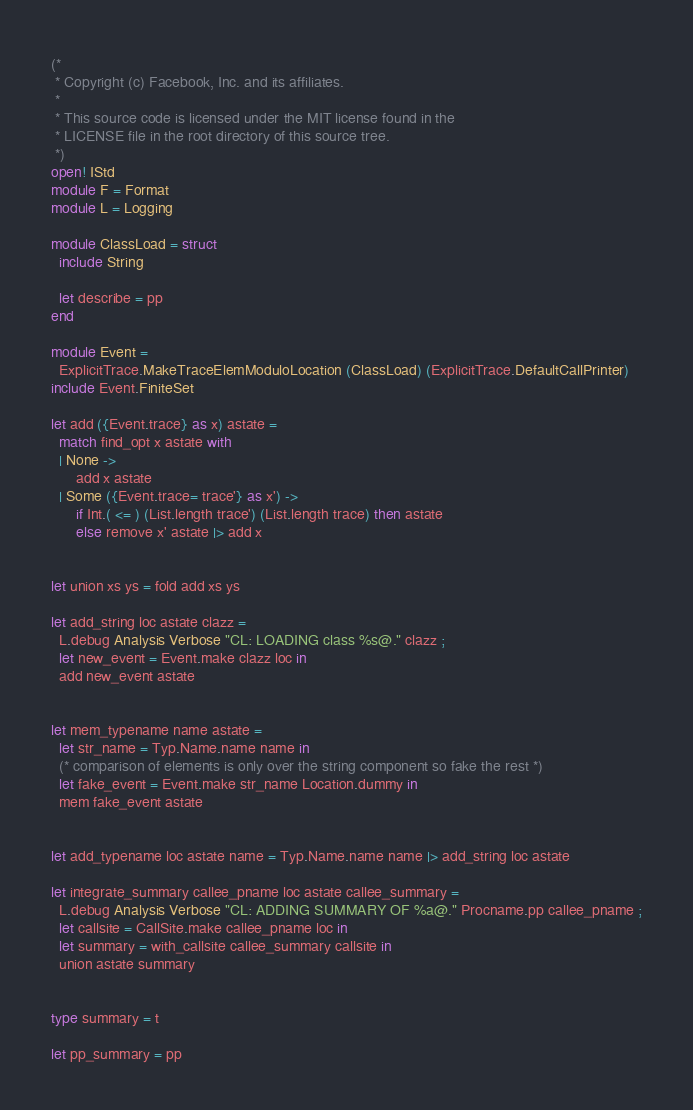<code> <loc_0><loc_0><loc_500><loc_500><_OCaml_>(*
 * Copyright (c) Facebook, Inc. and its affiliates.
 *
 * This source code is licensed under the MIT license found in the
 * LICENSE file in the root directory of this source tree.
 *)
open! IStd
module F = Format
module L = Logging

module ClassLoad = struct
  include String

  let describe = pp
end

module Event =
  ExplicitTrace.MakeTraceElemModuloLocation (ClassLoad) (ExplicitTrace.DefaultCallPrinter)
include Event.FiniteSet

let add ({Event.trace} as x) astate =
  match find_opt x astate with
  | None ->
      add x astate
  | Some ({Event.trace= trace'} as x') ->
      if Int.( <= ) (List.length trace') (List.length trace) then astate
      else remove x' astate |> add x


let union xs ys = fold add xs ys

let add_string loc astate clazz =
  L.debug Analysis Verbose "CL: LOADING class %s@." clazz ;
  let new_event = Event.make clazz loc in
  add new_event astate


let mem_typename name astate =
  let str_name = Typ.Name.name name in
  (* comparison of elements is only over the string component so fake the rest *)
  let fake_event = Event.make str_name Location.dummy in
  mem fake_event astate


let add_typename loc astate name = Typ.Name.name name |> add_string loc astate

let integrate_summary callee_pname loc astate callee_summary =
  L.debug Analysis Verbose "CL: ADDING SUMMARY OF %a@." Procname.pp callee_pname ;
  let callsite = CallSite.make callee_pname loc in
  let summary = with_callsite callee_summary callsite in
  union astate summary


type summary = t

let pp_summary = pp
</code> 